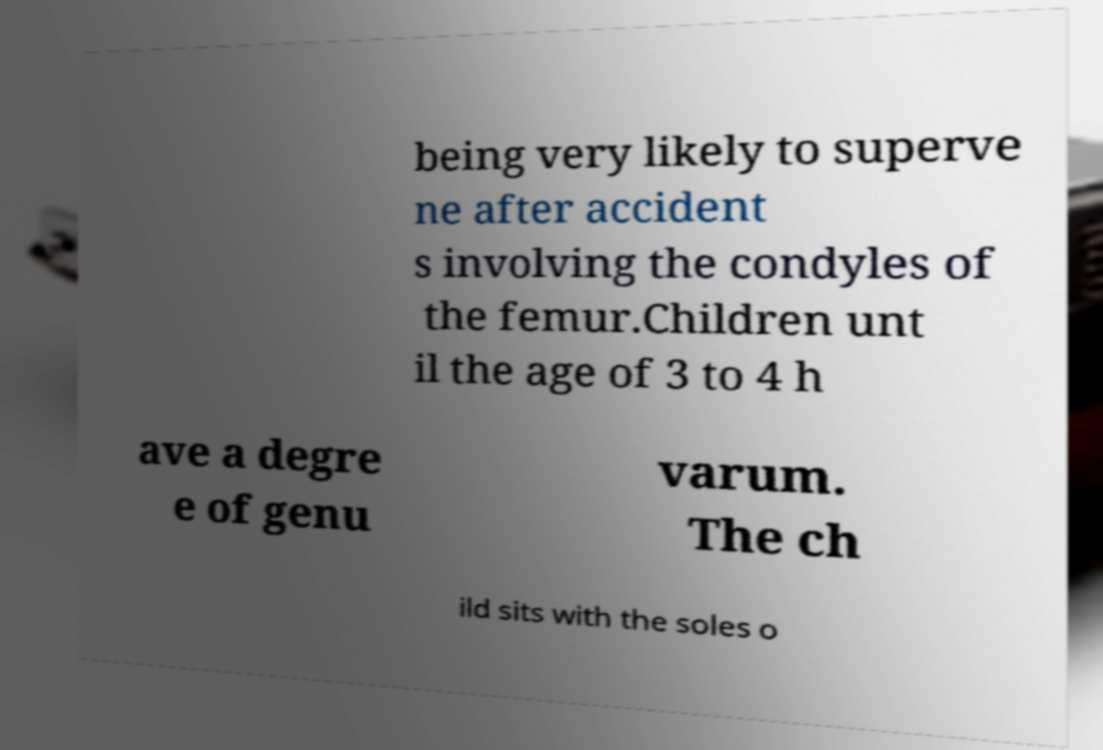Can you accurately transcribe the text from the provided image for me? being very likely to superve ne after accident s involving the condyles of the femur.Children unt il the age of 3 to 4 h ave a degre e of genu varum. The ch ild sits with the soles o 